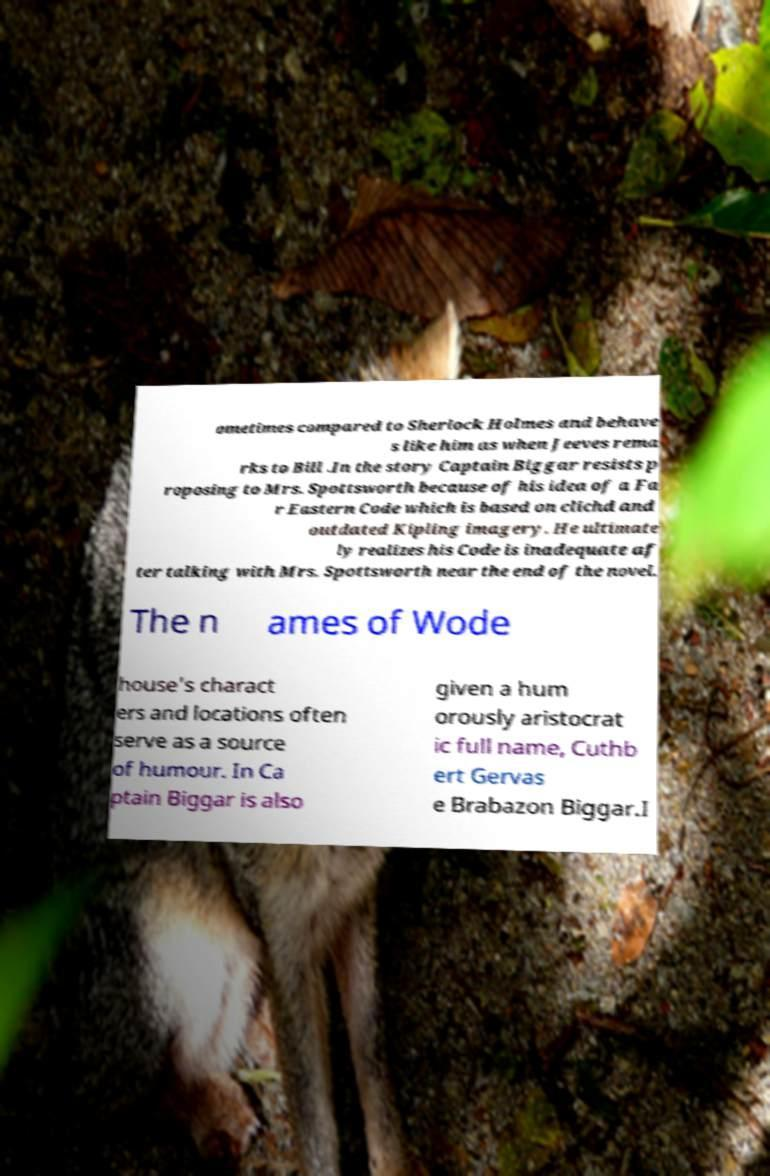Please identify and transcribe the text found in this image. ometimes compared to Sherlock Holmes and behave s like him as when Jeeves rema rks to Bill .In the story Captain Biggar resists p roposing to Mrs. Spottsworth because of his idea of a Fa r Eastern Code which is based on clichd and outdated Kipling imagery. He ultimate ly realizes his Code is inadequate af ter talking with Mrs. Spottsworth near the end of the novel. The n ames of Wode house's charact ers and locations often serve as a source of humour. In Ca ptain Biggar is also given a hum orously aristocrat ic full name, Cuthb ert Gervas e Brabazon Biggar.I 